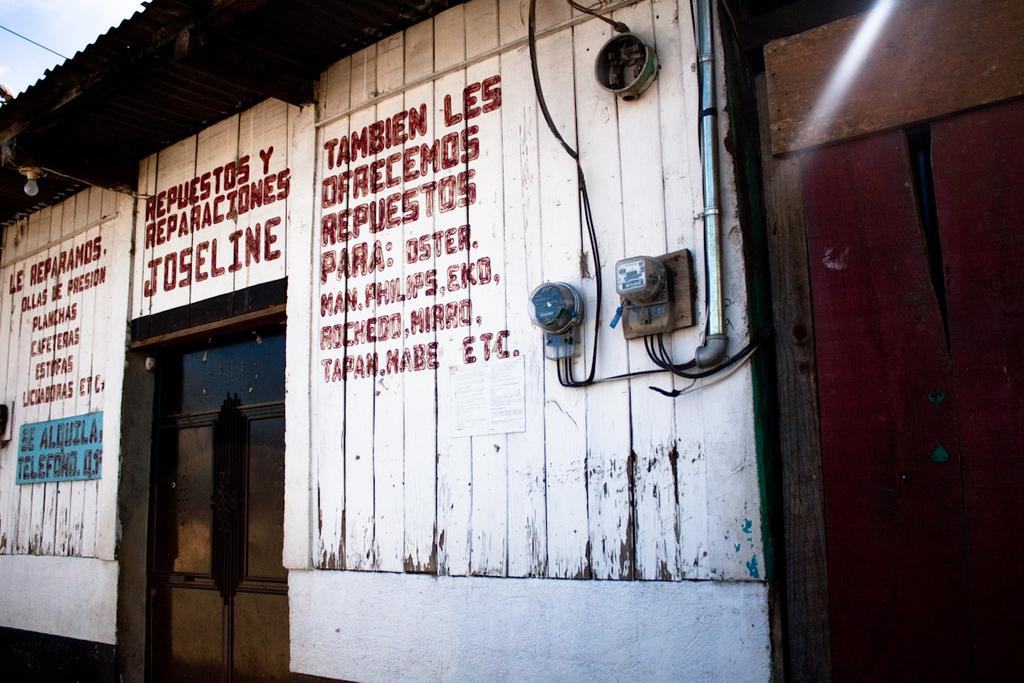What type of structure is visible in the image? There is a house in the image. What objects can be seen near the house? There are boxes and a pipe visible in the image. What is written or drawn on a wall in the image? There is text on a wall in the image. What type of lighting is present in the image? There is a bulb in the image. What type of music can be heard playing in the background of the image? There is no music present in the image, as it is a static visual representation. 